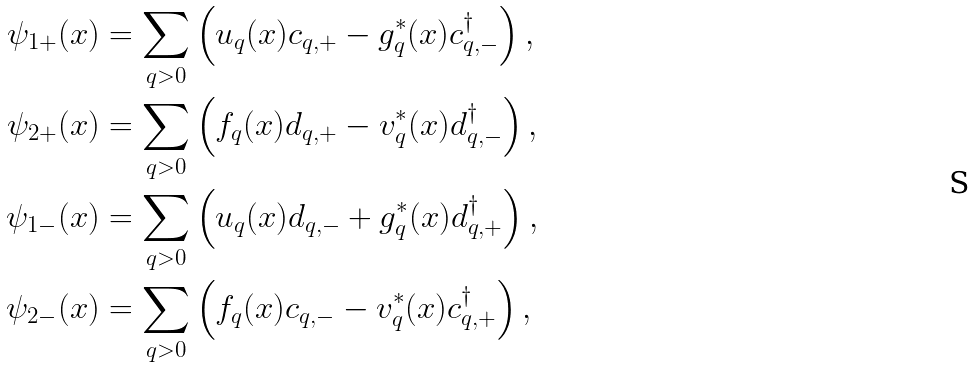Convert formula to latex. <formula><loc_0><loc_0><loc_500><loc_500>\psi _ { 1 + } ( x ) & = \sum _ { q > 0 } \left ( u _ { q } ( x ) c _ { q , + } - g _ { q } ^ { * } ( x ) c _ { q , - } ^ { \dagger } \right ) , \\ \psi _ { 2 + } ( x ) & = \sum _ { q > 0 } \left ( f _ { q } ( x ) d _ { q , + } - v _ { q } ^ { * } ( x ) d _ { q , - } ^ { \dagger } \right ) , \\ \psi _ { 1 - } ( x ) & = \sum _ { q > 0 } \left ( u _ { q } ( x ) d _ { q , - } + g _ { q } ^ { * } ( x ) d _ { q , + } ^ { \dagger } \right ) , \\ \psi _ { 2 - } ( x ) & = \sum _ { q > 0 } \left ( f _ { q } ( x ) c _ { q , - } - v _ { q } ^ { * } ( x ) c _ { q , + } ^ { \dagger } \right ) ,</formula> 